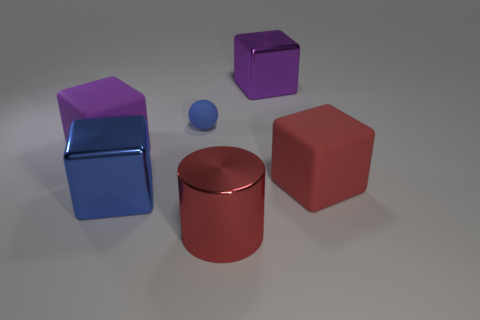Add 2 red rubber blocks. How many objects exist? 8 Subtract all cylinders. How many objects are left? 5 Add 5 brown cylinders. How many brown cylinders exist? 5 Subtract 0 brown spheres. How many objects are left? 6 Subtract all small cyan matte balls. Subtract all large red blocks. How many objects are left? 5 Add 3 big purple things. How many big purple things are left? 5 